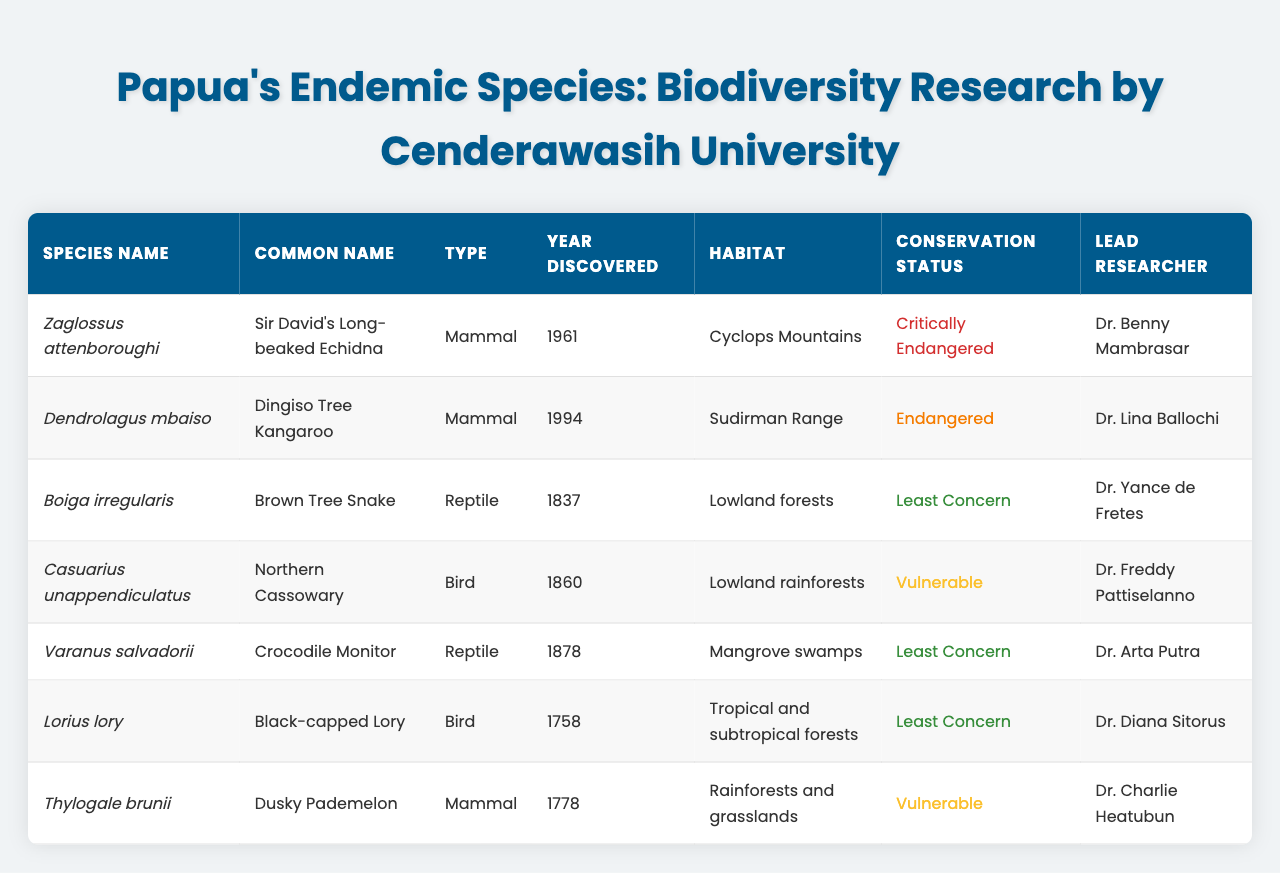What is the conservation status of Zaglossus attenboroughi? The table indicates that Zaglossus attenboroughi has a conservation status of "Critically Endangered."
Answer: Critically Endangered Who is the lead researcher for Dendrolagus mbaiso? According to the table, the lead researcher for Dendrolagus mbaiso is Dr. Lina Ballochi.
Answer: Dr. Lina Ballochi How many species listed were discovered after 1970? The species discovered after 1970 are Dendrolagus mbaiso (1994) and Zaglossus attenboroughi (1961), totaling two species.
Answer: 2 Which type of species has the highest number of entries in the table? After analyzing the table, there are four mammals, two reptiles, and two birds. Thus, mammals have the highest count with four entries.
Answer: Mammals What is the habitat of Casuarius unappendiculatus? The table states that Casuarius unappendiculatus inhabits lowland rainforests.
Answer: Lowland rainforests Is Boiga irregularis classified as endangered? The table shows that Boiga irregularis is classified as "Least Concern," indicating it is not endangered.
Answer: No Which species have been classified as vulnerable? The species classified as vulnerable in the table are Casuarius unappendiculatus and Thylogale brunii.
Answer: Casuarius unappendiculatus and Thylogale brunii What is the difference in the year discovered between the oldest and the youngest species? The oldest species is Lorius lory, discovered in 1758, and the youngest is Dendrolagus mbaiso, discovered in 1994. The difference is 1994 - 1758 = 236 years.
Answer: 236 years Which lead researcher studies a species in mangrove swamps? The table indicates that Dr. Arta Putra studies Varanus salvadorii, which is found in mangrove swamps.
Answer: Dr. Arta Putra Are any of the listed species discovered in the 1800s endangered? The only species discovered in the 1800s that is endangered is Casuarius unappendiculatus, classified as "Vulnerable." The other two discovered in that century are classified as "Least Concern."
Answer: Yes 